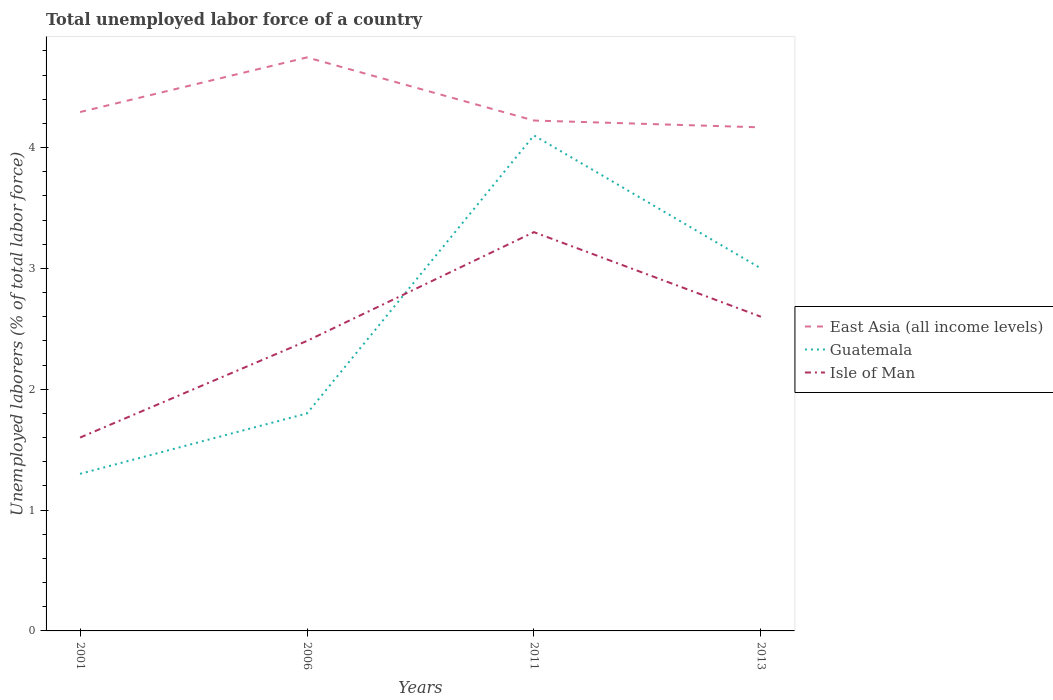Does the line corresponding to Isle of Man intersect with the line corresponding to East Asia (all income levels)?
Make the answer very short. No. Is the number of lines equal to the number of legend labels?
Ensure brevity in your answer.  Yes. Across all years, what is the maximum total unemployed labor force in East Asia (all income levels)?
Offer a terse response. 4.17. In which year was the total unemployed labor force in East Asia (all income levels) maximum?
Your answer should be compact. 2013. What is the total total unemployed labor force in East Asia (all income levels) in the graph?
Your answer should be compact. -0.45. What is the difference between the highest and the second highest total unemployed labor force in Guatemala?
Keep it short and to the point. 2.8. What is the difference between the highest and the lowest total unemployed labor force in Guatemala?
Your answer should be compact. 2. Is the total unemployed labor force in Guatemala strictly greater than the total unemployed labor force in East Asia (all income levels) over the years?
Your response must be concise. Yes. How many lines are there?
Keep it short and to the point. 3. What is the difference between two consecutive major ticks on the Y-axis?
Give a very brief answer. 1. Where does the legend appear in the graph?
Offer a very short reply. Center right. How many legend labels are there?
Your response must be concise. 3. How are the legend labels stacked?
Provide a short and direct response. Vertical. What is the title of the graph?
Offer a very short reply. Total unemployed labor force of a country. Does "High income: nonOECD" appear as one of the legend labels in the graph?
Give a very brief answer. No. What is the label or title of the Y-axis?
Offer a terse response. Unemployed laborers (% of total labor force). What is the Unemployed laborers (% of total labor force) in East Asia (all income levels) in 2001?
Ensure brevity in your answer.  4.29. What is the Unemployed laborers (% of total labor force) in Guatemala in 2001?
Your answer should be compact. 1.3. What is the Unemployed laborers (% of total labor force) in Isle of Man in 2001?
Your answer should be very brief. 1.6. What is the Unemployed laborers (% of total labor force) of East Asia (all income levels) in 2006?
Your answer should be compact. 4.75. What is the Unemployed laborers (% of total labor force) of Guatemala in 2006?
Provide a short and direct response. 1.8. What is the Unemployed laborers (% of total labor force) of Isle of Man in 2006?
Make the answer very short. 2.4. What is the Unemployed laborers (% of total labor force) of East Asia (all income levels) in 2011?
Your answer should be very brief. 4.22. What is the Unemployed laborers (% of total labor force) of Guatemala in 2011?
Your response must be concise. 4.1. What is the Unemployed laborers (% of total labor force) of Isle of Man in 2011?
Your response must be concise. 3.3. What is the Unemployed laborers (% of total labor force) in East Asia (all income levels) in 2013?
Your answer should be very brief. 4.17. What is the Unemployed laborers (% of total labor force) in Isle of Man in 2013?
Ensure brevity in your answer.  2.6. Across all years, what is the maximum Unemployed laborers (% of total labor force) of East Asia (all income levels)?
Provide a succinct answer. 4.75. Across all years, what is the maximum Unemployed laborers (% of total labor force) of Guatemala?
Your answer should be compact. 4.1. Across all years, what is the maximum Unemployed laborers (% of total labor force) of Isle of Man?
Your answer should be compact. 3.3. Across all years, what is the minimum Unemployed laborers (% of total labor force) in East Asia (all income levels)?
Keep it short and to the point. 4.17. Across all years, what is the minimum Unemployed laborers (% of total labor force) in Guatemala?
Offer a very short reply. 1.3. Across all years, what is the minimum Unemployed laborers (% of total labor force) in Isle of Man?
Ensure brevity in your answer.  1.6. What is the total Unemployed laborers (% of total labor force) of East Asia (all income levels) in the graph?
Your response must be concise. 17.43. What is the difference between the Unemployed laborers (% of total labor force) of East Asia (all income levels) in 2001 and that in 2006?
Give a very brief answer. -0.45. What is the difference between the Unemployed laborers (% of total labor force) in Isle of Man in 2001 and that in 2006?
Offer a very short reply. -0.8. What is the difference between the Unemployed laborers (% of total labor force) of East Asia (all income levels) in 2001 and that in 2011?
Offer a very short reply. 0.07. What is the difference between the Unemployed laborers (% of total labor force) of East Asia (all income levels) in 2001 and that in 2013?
Offer a very short reply. 0.13. What is the difference between the Unemployed laborers (% of total labor force) in East Asia (all income levels) in 2006 and that in 2011?
Provide a short and direct response. 0.52. What is the difference between the Unemployed laborers (% of total labor force) in Isle of Man in 2006 and that in 2011?
Give a very brief answer. -0.9. What is the difference between the Unemployed laborers (% of total labor force) in East Asia (all income levels) in 2006 and that in 2013?
Ensure brevity in your answer.  0.58. What is the difference between the Unemployed laborers (% of total labor force) of Isle of Man in 2006 and that in 2013?
Offer a terse response. -0.2. What is the difference between the Unemployed laborers (% of total labor force) of East Asia (all income levels) in 2011 and that in 2013?
Keep it short and to the point. 0.06. What is the difference between the Unemployed laborers (% of total labor force) of Guatemala in 2011 and that in 2013?
Give a very brief answer. 1.1. What is the difference between the Unemployed laborers (% of total labor force) in East Asia (all income levels) in 2001 and the Unemployed laborers (% of total labor force) in Guatemala in 2006?
Keep it short and to the point. 2.49. What is the difference between the Unemployed laborers (% of total labor force) of East Asia (all income levels) in 2001 and the Unemployed laborers (% of total labor force) of Isle of Man in 2006?
Provide a short and direct response. 1.89. What is the difference between the Unemployed laborers (% of total labor force) of East Asia (all income levels) in 2001 and the Unemployed laborers (% of total labor force) of Guatemala in 2011?
Provide a succinct answer. 0.19. What is the difference between the Unemployed laborers (% of total labor force) in East Asia (all income levels) in 2001 and the Unemployed laborers (% of total labor force) in Guatemala in 2013?
Provide a succinct answer. 1.29. What is the difference between the Unemployed laborers (% of total labor force) in East Asia (all income levels) in 2001 and the Unemployed laborers (% of total labor force) in Isle of Man in 2013?
Your response must be concise. 1.69. What is the difference between the Unemployed laborers (% of total labor force) of Guatemala in 2001 and the Unemployed laborers (% of total labor force) of Isle of Man in 2013?
Your answer should be compact. -1.3. What is the difference between the Unemployed laborers (% of total labor force) in East Asia (all income levels) in 2006 and the Unemployed laborers (% of total labor force) in Guatemala in 2011?
Ensure brevity in your answer.  0.65. What is the difference between the Unemployed laborers (% of total labor force) in East Asia (all income levels) in 2006 and the Unemployed laborers (% of total labor force) in Isle of Man in 2011?
Offer a very short reply. 1.45. What is the difference between the Unemployed laborers (% of total labor force) of Guatemala in 2006 and the Unemployed laborers (% of total labor force) of Isle of Man in 2011?
Keep it short and to the point. -1.5. What is the difference between the Unemployed laborers (% of total labor force) of East Asia (all income levels) in 2006 and the Unemployed laborers (% of total labor force) of Guatemala in 2013?
Your response must be concise. 1.75. What is the difference between the Unemployed laborers (% of total labor force) in East Asia (all income levels) in 2006 and the Unemployed laborers (% of total labor force) in Isle of Man in 2013?
Your answer should be compact. 2.15. What is the difference between the Unemployed laborers (% of total labor force) in Guatemala in 2006 and the Unemployed laborers (% of total labor force) in Isle of Man in 2013?
Provide a succinct answer. -0.8. What is the difference between the Unemployed laborers (% of total labor force) of East Asia (all income levels) in 2011 and the Unemployed laborers (% of total labor force) of Guatemala in 2013?
Make the answer very short. 1.22. What is the difference between the Unemployed laborers (% of total labor force) in East Asia (all income levels) in 2011 and the Unemployed laborers (% of total labor force) in Isle of Man in 2013?
Offer a very short reply. 1.62. What is the average Unemployed laborers (% of total labor force) in East Asia (all income levels) per year?
Keep it short and to the point. 4.36. What is the average Unemployed laborers (% of total labor force) of Guatemala per year?
Your response must be concise. 2.55. What is the average Unemployed laborers (% of total labor force) in Isle of Man per year?
Provide a succinct answer. 2.48. In the year 2001, what is the difference between the Unemployed laborers (% of total labor force) in East Asia (all income levels) and Unemployed laborers (% of total labor force) in Guatemala?
Offer a terse response. 2.99. In the year 2001, what is the difference between the Unemployed laborers (% of total labor force) of East Asia (all income levels) and Unemployed laborers (% of total labor force) of Isle of Man?
Ensure brevity in your answer.  2.69. In the year 2006, what is the difference between the Unemployed laborers (% of total labor force) in East Asia (all income levels) and Unemployed laborers (% of total labor force) in Guatemala?
Give a very brief answer. 2.95. In the year 2006, what is the difference between the Unemployed laborers (% of total labor force) in East Asia (all income levels) and Unemployed laborers (% of total labor force) in Isle of Man?
Your answer should be compact. 2.35. In the year 2006, what is the difference between the Unemployed laborers (% of total labor force) in Guatemala and Unemployed laborers (% of total labor force) in Isle of Man?
Offer a terse response. -0.6. In the year 2011, what is the difference between the Unemployed laborers (% of total labor force) of East Asia (all income levels) and Unemployed laborers (% of total labor force) of Guatemala?
Your answer should be very brief. 0.12. In the year 2011, what is the difference between the Unemployed laborers (% of total labor force) of East Asia (all income levels) and Unemployed laborers (% of total labor force) of Isle of Man?
Your answer should be very brief. 0.92. In the year 2013, what is the difference between the Unemployed laborers (% of total labor force) of East Asia (all income levels) and Unemployed laborers (% of total labor force) of Guatemala?
Your answer should be very brief. 1.17. In the year 2013, what is the difference between the Unemployed laborers (% of total labor force) of East Asia (all income levels) and Unemployed laborers (% of total labor force) of Isle of Man?
Make the answer very short. 1.57. What is the ratio of the Unemployed laborers (% of total labor force) of East Asia (all income levels) in 2001 to that in 2006?
Offer a very short reply. 0.9. What is the ratio of the Unemployed laborers (% of total labor force) in Guatemala in 2001 to that in 2006?
Keep it short and to the point. 0.72. What is the ratio of the Unemployed laborers (% of total labor force) in Isle of Man in 2001 to that in 2006?
Provide a succinct answer. 0.67. What is the ratio of the Unemployed laborers (% of total labor force) in East Asia (all income levels) in 2001 to that in 2011?
Your answer should be compact. 1.02. What is the ratio of the Unemployed laborers (% of total labor force) in Guatemala in 2001 to that in 2011?
Make the answer very short. 0.32. What is the ratio of the Unemployed laborers (% of total labor force) in Isle of Man in 2001 to that in 2011?
Provide a short and direct response. 0.48. What is the ratio of the Unemployed laborers (% of total labor force) of East Asia (all income levels) in 2001 to that in 2013?
Your answer should be compact. 1.03. What is the ratio of the Unemployed laborers (% of total labor force) in Guatemala in 2001 to that in 2013?
Give a very brief answer. 0.43. What is the ratio of the Unemployed laborers (% of total labor force) of Isle of Man in 2001 to that in 2013?
Your answer should be compact. 0.62. What is the ratio of the Unemployed laborers (% of total labor force) of East Asia (all income levels) in 2006 to that in 2011?
Keep it short and to the point. 1.12. What is the ratio of the Unemployed laborers (% of total labor force) of Guatemala in 2006 to that in 2011?
Your answer should be very brief. 0.44. What is the ratio of the Unemployed laborers (% of total labor force) of Isle of Man in 2006 to that in 2011?
Your response must be concise. 0.73. What is the ratio of the Unemployed laborers (% of total labor force) in East Asia (all income levels) in 2006 to that in 2013?
Give a very brief answer. 1.14. What is the ratio of the Unemployed laborers (% of total labor force) of East Asia (all income levels) in 2011 to that in 2013?
Offer a terse response. 1.01. What is the ratio of the Unemployed laborers (% of total labor force) of Guatemala in 2011 to that in 2013?
Provide a succinct answer. 1.37. What is the ratio of the Unemployed laborers (% of total labor force) of Isle of Man in 2011 to that in 2013?
Your answer should be very brief. 1.27. What is the difference between the highest and the second highest Unemployed laborers (% of total labor force) in East Asia (all income levels)?
Your answer should be compact. 0.45. What is the difference between the highest and the second highest Unemployed laborers (% of total labor force) in Isle of Man?
Your answer should be compact. 0.7. What is the difference between the highest and the lowest Unemployed laborers (% of total labor force) in East Asia (all income levels)?
Offer a terse response. 0.58. What is the difference between the highest and the lowest Unemployed laborers (% of total labor force) in Guatemala?
Ensure brevity in your answer.  2.8. 